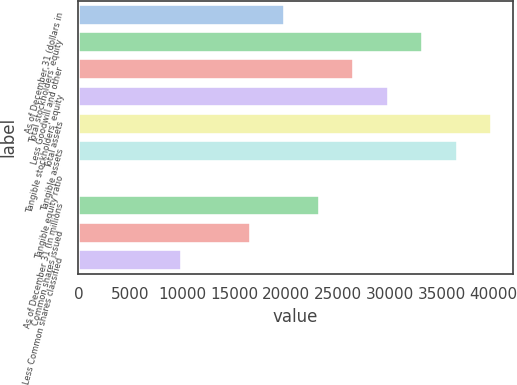<chart> <loc_0><loc_0><loc_500><loc_500><bar_chart><fcel>As of December 31 (dollars in<fcel>Total stockholders' equity<fcel>Less Goodwill and other<fcel>Tangible stockholders' equity<fcel>Total assets<fcel>Tangible assets<fcel>Tangible equity ratio<fcel>As of December 31 (in millions<fcel>Common shares issued<fcel>Less Common shares classified<nl><fcel>19931.6<fcel>33214<fcel>26572.8<fcel>29893.4<fcel>39855.2<fcel>36534.6<fcel>7.9<fcel>23252.2<fcel>16611<fcel>9969.73<nl></chart> 